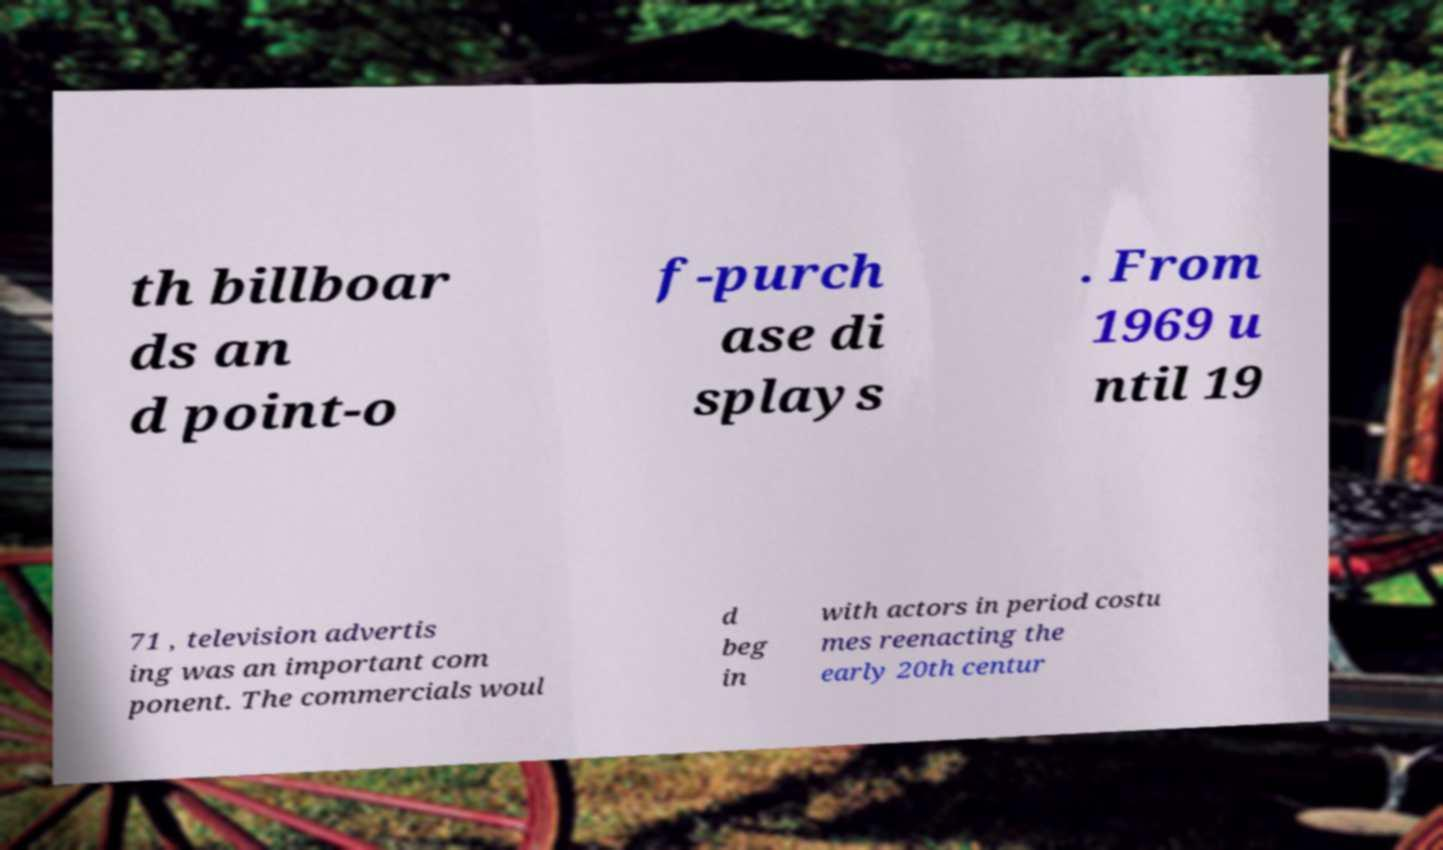Can you accurately transcribe the text from the provided image for me? th billboar ds an d point-o f-purch ase di splays . From 1969 u ntil 19 71 , television advertis ing was an important com ponent. The commercials woul d beg in with actors in period costu mes reenacting the early 20th centur 